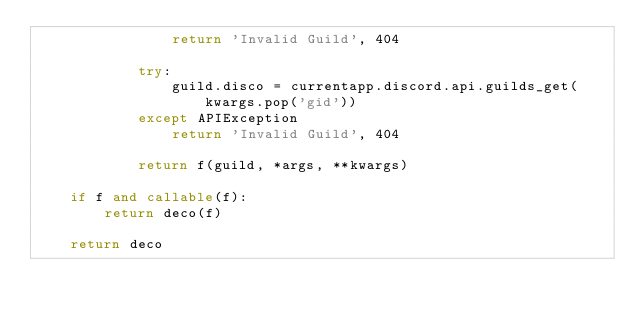Convert code to text. <code><loc_0><loc_0><loc_500><loc_500><_Python_>                return 'Invalid Guild', 404
            
            try:
                guild.disco = currentapp.discord.api.guilds_get(kwargs.pop('gid'))
            except APIException
                return 'Invalid Guild', 404

            return f(guild, *args, **kwargs)

    if f and callable(f):
        return deco(f)

    return deco</code> 